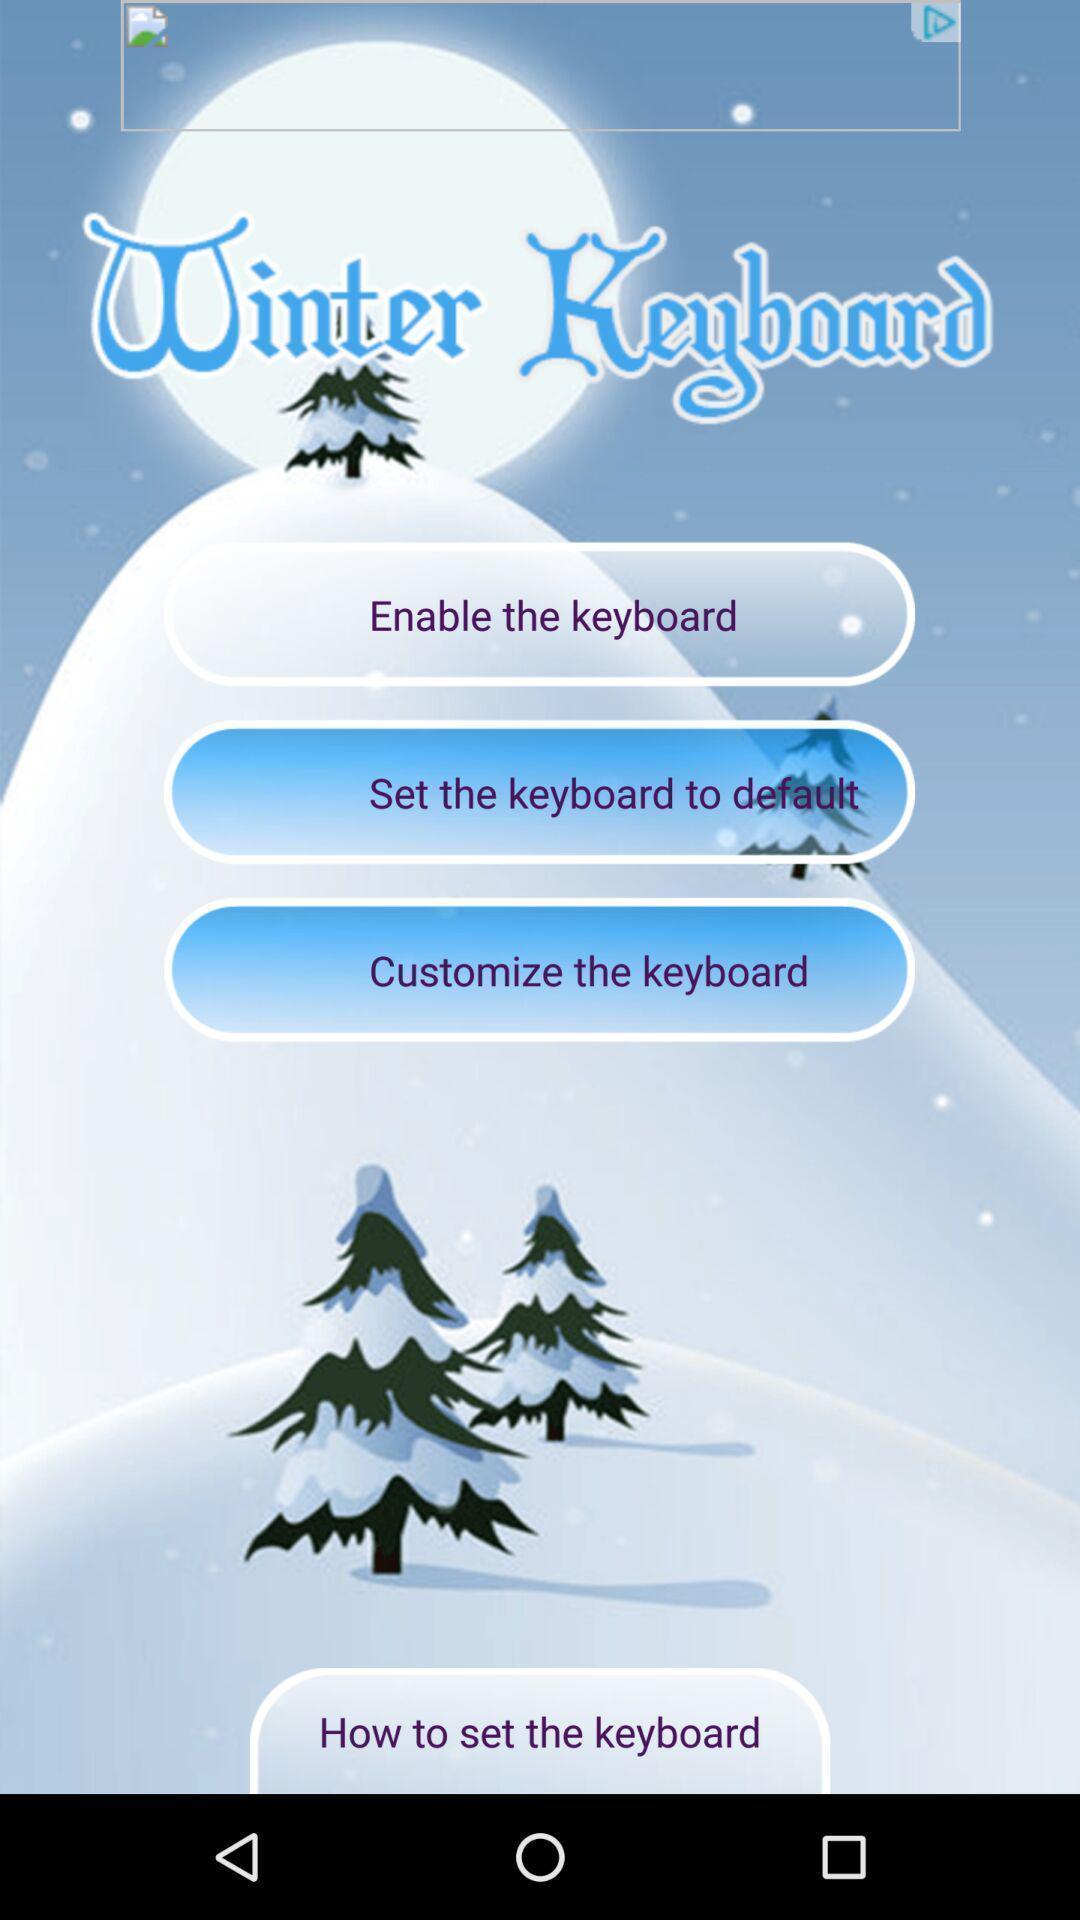Provide a description of this screenshot. Welcome page. 